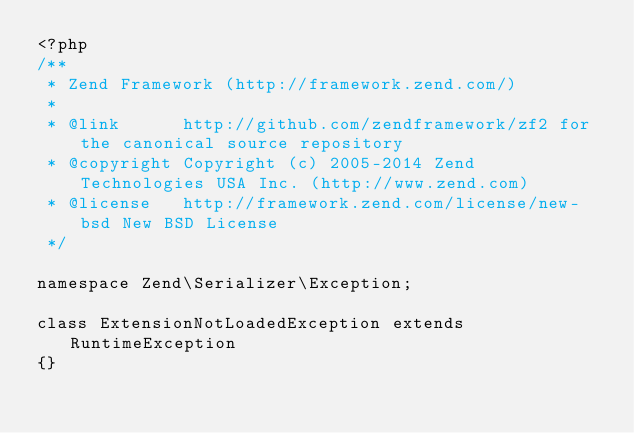<code> <loc_0><loc_0><loc_500><loc_500><_PHP_><?php
/**
 * Zend Framework (http://framework.zend.com/)
 *
 * @link      http://github.com/zendframework/zf2 for the canonical source repository
 * @copyright Copyright (c) 2005-2014 Zend Technologies USA Inc. (http://www.zend.com)
 * @license   http://framework.zend.com/license/new-bsd New BSD License
 */

namespace Zend\Serializer\Exception;

class ExtensionNotLoadedException extends RuntimeException
{}
</code> 